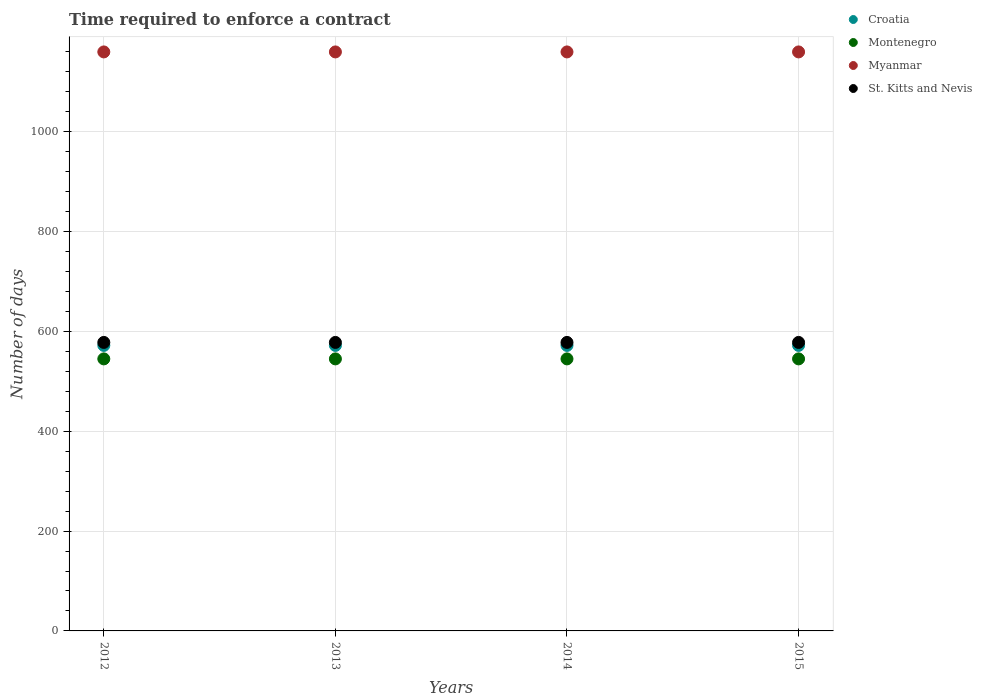What is the number of days required to enforce a contract in Croatia in 2012?
Give a very brief answer. 572. Across all years, what is the maximum number of days required to enforce a contract in St. Kitts and Nevis?
Provide a succinct answer. 578. Across all years, what is the minimum number of days required to enforce a contract in Croatia?
Offer a terse response. 572. In which year was the number of days required to enforce a contract in Croatia maximum?
Your answer should be compact. 2012. In which year was the number of days required to enforce a contract in St. Kitts and Nevis minimum?
Provide a short and direct response. 2012. What is the total number of days required to enforce a contract in Myanmar in the graph?
Your answer should be compact. 4640. What is the difference between the number of days required to enforce a contract in Myanmar in 2015 and the number of days required to enforce a contract in St. Kitts and Nevis in 2013?
Give a very brief answer. 582. What is the average number of days required to enforce a contract in St. Kitts and Nevis per year?
Ensure brevity in your answer.  578. In the year 2012, what is the difference between the number of days required to enforce a contract in Myanmar and number of days required to enforce a contract in St. Kitts and Nevis?
Your answer should be very brief. 582. Is the difference between the number of days required to enforce a contract in Myanmar in 2014 and 2015 greater than the difference between the number of days required to enforce a contract in St. Kitts and Nevis in 2014 and 2015?
Give a very brief answer. No. What is the difference between the highest and the second highest number of days required to enforce a contract in Croatia?
Offer a terse response. 0. Is the number of days required to enforce a contract in Croatia strictly greater than the number of days required to enforce a contract in Myanmar over the years?
Offer a very short reply. No. Is the number of days required to enforce a contract in Myanmar strictly less than the number of days required to enforce a contract in Croatia over the years?
Keep it short and to the point. No. How many years are there in the graph?
Give a very brief answer. 4. What is the difference between two consecutive major ticks on the Y-axis?
Offer a very short reply. 200. Are the values on the major ticks of Y-axis written in scientific E-notation?
Your response must be concise. No. Does the graph contain grids?
Your response must be concise. Yes. How many legend labels are there?
Your answer should be compact. 4. What is the title of the graph?
Make the answer very short. Time required to enforce a contract. What is the label or title of the X-axis?
Provide a short and direct response. Years. What is the label or title of the Y-axis?
Your answer should be very brief. Number of days. What is the Number of days of Croatia in 2012?
Ensure brevity in your answer.  572. What is the Number of days in Montenegro in 2012?
Provide a short and direct response. 545. What is the Number of days in Myanmar in 2012?
Keep it short and to the point. 1160. What is the Number of days of St. Kitts and Nevis in 2012?
Offer a terse response. 578. What is the Number of days in Croatia in 2013?
Ensure brevity in your answer.  572. What is the Number of days in Montenegro in 2013?
Offer a terse response. 545. What is the Number of days of Myanmar in 2013?
Your response must be concise. 1160. What is the Number of days of St. Kitts and Nevis in 2013?
Your response must be concise. 578. What is the Number of days of Croatia in 2014?
Make the answer very short. 572. What is the Number of days in Montenegro in 2014?
Provide a succinct answer. 545. What is the Number of days of Myanmar in 2014?
Your answer should be compact. 1160. What is the Number of days of St. Kitts and Nevis in 2014?
Give a very brief answer. 578. What is the Number of days in Croatia in 2015?
Ensure brevity in your answer.  572. What is the Number of days of Montenegro in 2015?
Give a very brief answer. 545. What is the Number of days in Myanmar in 2015?
Keep it short and to the point. 1160. What is the Number of days in St. Kitts and Nevis in 2015?
Your answer should be very brief. 578. Across all years, what is the maximum Number of days in Croatia?
Make the answer very short. 572. Across all years, what is the maximum Number of days of Montenegro?
Provide a short and direct response. 545. Across all years, what is the maximum Number of days of Myanmar?
Ensure brevity in your answer.  1160. Across all years, what is the maximum Number of days in St. Kitts and Nevis?
Offer a very short reply. 578. Across all years, what is the minimum Number of days in Croatia?
Provide a succinct answer. 572. Across all years, what is the minimum Number of days of Montenegro?
Offer a very short reply. 545. Across all years, what is the minimum Number of days in Myanmar?
Keep it short and to the point. 1160. Across all years, what is the minimum Number of days in St. Kitts and Nevis?
Provide a succinct answer. 578. What is the total Number of days of Croatia in the graph?
Your answer should be compact. 2288. What is the total Number of days of Montenegro in the graph?
Give a very brief answer. 2180. What is the total Number of days in Myanmar in the graph?
Offer a very short reply. 4640. What is the total Number of days of St. Kitts and Nevis in the graph?
Offer a terse response. 2312. What is the difference between the Number of days of Montenegro in 2012 and that in 2013?
Your response must be concise. 0. What is the difference between the Number of days in Myanmar in 2012 and that in 2013?
Make the answer very short. 0. What is the difference between the Number of days of St. Kitts and Nevis in 2012 and that in 2013?
Offer a terse response. 0. What is the difference between the Number of days in Montenegro in 2012 and that in 2014?
Give a very brief answer. 0. What is the difference between the Number of days in Myanmar in 2012 and that in 2014?
Give a very brief answer. 0. What is the difference between the Number of days of St. Kitts and Nevis in 2012 and that in 2014?
Make the answer very short. 0. What is the difference between the Number of days in Myanmar in 2012 and that in 2015?
Give a very brief answer. 0. What is the difference between the Number of days of St. Kitts and Nevis in 2012 and that in 2015?
Ensure brevity in your answer.  0. What is the difference between the Number of days in Croatia in 2013 and that in 2014?
Provide a short and direct response. 0. What is the difference between the Number of days of Montenegro in 2013 and that in 2014?
Offer a terse response. 0. What is the difference between the Number of days in Croatia in 2013 and that in 2015?
Give a very brief answer. 0. What is the difference between the Number of days in Myanmar in 2013 and that in 2015?
Your response must be concise. 0. What is the difference between the Number of days in Croatia in 2014 and that in 2015?
Your response must be concise. 0. What is the difference between the Number of days in St. Kitts and Nevis in 2014 and that in 2015?
Keep it short and to the point. 0. What is the difference between the Number of days in Croatia in 2012 and the Number of days in Myanmar in 2013?
Give a very brief answer. -588. What is the difference between the Number of days of Montenegro in 2012 and the Number of days of Myanmar in 2013?
Your response must be concise. -615. What is the difference between the Number of days of Montenegro in 2012 and the Number of days of St. Kitts and Nevis in 2013?
Offer a terse response. -33. What is the difference between the Number of days of Myanmar in 2012 and the Number of days of St. Kitts and Nevis in 2013?
Your answer should be very brief. 582. What is the difference between the Number of days of Croatia in 2012 and the Number of days of Montenegro in 2014?
Offer a terse response. 27. What is the difference between the Number of days in Croatia in 2012 and the Number of days in Myanmar in 2014?
Offer a terse response. -588. What is the difference between the Number of days in Montenegro in 2012 and the Number of days in Myanmar in 2014?
Give a very brief answer. -615. What is the difference between the Number of days of Montenegro in 2012 and the Number of days of St. Kitts and Nevis in 2014?
Provide a succinct answer. -33. What is the difference between the Number of days in Myanmar in 2012 and the Number of days in St. Kitts and Nevis in 2014?
Provide a succinct answer. 582. What is the difference between the Number of days of Croatia in 2012 and the Number of days of Myanmar in 2015?
Provide a short and direct response. -588. What is the difference between the Number of days in Croatia in 2012 and the Number of days in St. Kitts and Nevis in 2015?
Provide a succinct answer. -6. What is the difference between the Number of days of Montenegro in 2012 and the Number of days of Myanmar in 2015?
Your answer should be compact. -615. What is the difference between the Number of days of Montenegro in 2012 and the Number of days of St. Kitts and Nevis in 2015?
Keep it short and to the point. -33. What is the difference between the Number of days in Myanmar in 2012 and the Number of days in St. Kitts and Nevis in 2015?
Ensure brevity in your answer.  582. What is the difference between the Number of days of Croatia in 2013 and the Number of days of Montenegro in 2014?
Provide a short and direct response. 27. What is the difference between the Number of days in Croatia in 2013 and the Number of days in Myanmar in 2014?
Your answer should be compact. -588. What is the difference between the Number of days of Croatia in 2013 and the Number of days of St. Kitts and Nevis in 2014?
Your answer should be compact. -6. What is the difference between the Number of days of Montenegro in 2013 and the Number of days of Myanmar in 2014?
Provide a short and direct response. -615. What is the difference between the Number of days of Montenegro in 2013 and the Number of days of St. Kitts and Nevis in 2014?
Ensure brevity in your answer.  -33. What is the difference between the Number of days of Myanmar in 2013 and the Number of days of St. Kitts and Nevis in 2014?
Make the answer very short. 582. What is the difference between the Number of days of Croatia in 2013 and the Number of days of Montenegro in 2015?
Your answer should be very brief. 27. What is the difference between the Number of days of Croatia in 2013 and the Number of days of Myanmar in 2015?
Provide a succinct answer. -588. What is the difference between the Number of days in Croatia in 2013 and the Number of days in St. Kitts and Nevis in 2015?
Provide a succinct answer. -6. What is the difference between the Number of days in Montenegro in 2013 and the Number of days in Myanmar in 2015?
Provide a short and direct response. -615. What is the difference between the Number of days in Montenegro in 2013 and the Number of days in St. Kitts and Nevis in 2015?
Provide a succinct answer. -33. What is the difference between the Number of days of Myanmar in 2013 and the Number of days of St. Kitts and Nevis in 2015?
Your answer should be compact. 582. What is the difference between the Number of days of Croatia in 2014 and the Number of days of Montenegro in 2015?
Offer a terse response. 27. What is the difference between the Number of days in Croatia in 2014 and the Number of days in Myanmar in 2015?
Offer a terse response. -588. What is the difference between the Number of days in Montenegro in 2014 and the Number of days in Myanmar in 2015?
Offer a terse response. -615. What is the difference between the Number of days of Montenegro in 2014 and the Number of days of St. Kitts and Nevis in 2015?
Offer a very short reply. -33. What is the difference between the Number of days in Myanmar in 2014 and the Number of days in St. Kitts and Nevis in 2015?
Give a very brief answer. 582. What is the average Number of days of Croatia per year?
Provide a short and direct response. 572. What is the average Number of days in Montenegro per year?
Keep it short and to the point. 545. What is the average Number of days of Myanmar per year?
Keep it short and to the point. 1160. What is the average Number of days of St. Kitts and Nevis per year?
Keep it short and to the point. 578. In the year 2012, what is the difference between the Number of days in Croatia and Number of days in Montenegro?
Keep it short and to the point. 27. In the year 2012, what is the difference between the Number of days of Croatia and Number of days of Myanmar?
Make the answer very short. -588. In the year 2012, what is the difference between the Number of days of Montenegro and Number of days of Myanmar?
Your answer should be compact. -615. In the year 2012, what is the difference between the Number of days in Montenegro and Number of days in St. Kitts and Nevis?
Make the answer very short. -33. In the year 2012, what is the difference between the Number of days in Myanmar and Number of days in St. Kitts and Nevis?
Your answer should be very brief. 582. In the year 2013, what is the difference between the Number of days in Croatia and Number of days in Myanmar?
Your response must be concise. -588. In the year 2013, what is the difference between the Number of days of Croatia and Number of days of St. Kitts and Nevis?
Your answer should be very brief. -6. In the year 2013, what is the difference between the Number of days of Montenegro and Number of days of Myanmar?
Your answer should be compact. -615. In the year 2013, what is the difference between the Number of days of Montenegro and Number of days of St. Kitts and Nevis?
Keep it short and to the point. -33. In the year 2013, what is the difference between the Number of days of Myanmar and Number of days of St. Kitts and Nevis?
Give a very brief answer. 582. In the year 2014, what is the difference between the Number of days of Croatia and Number of days of Myanmar?
Provide a short and direct response. -588. In the year 2014, what is the difference between the Number of days in Croatia and Number of days in St. Kitts and Nevis?
Provide a succinct answer. -6. In the year 2014, what is the difference between the Number of days of Montenegro and Number of days of Myanmar?
Offer a very short reply. -615. In the year 2014, what is the difference between the Number of days of Montenegro and Number of days of St. Kitts and Nevis?
Ensure brevity in your answer.  -33. In the year 2014, what is the difference between the Number of days in Myanmar and Number of days in St. Kitts and Nevis?
Keep it short and to the point. 582. In the year 2015, what is the difference between the Number of days in Croatia and Number of days in Myanmar?
Offer a terse response. -588. In the year 2015, what is the difference between the Number of days in Croatia and Number of days in St. Kitts and Nevis?
Provide a succinct answer. -6. In the year 2015, what is the difference between the Number of days in Montenegro and Number of days in Myanmar?
Provide a succinct answer. -615. In the year 2015, what is the difference between the Number of days of Montenegro and Number of days of St. Kitts and Nevis?
Your response must be concise. -33. In the year 2015, what is the difference between the Number of days of Myanmar and Number of days of St. Kitts and Nevis?
Keep it short and to the point. 582. What is the ratio of the Number of days in Montenegro in 2012 to that in 2013?
Your answer should be compact. 1. What is the ratio of the Number of days in Croatia in 2012 to that in 2014?
Your answer should be compact. 1. What is the ratio of the Number of days in St. Kitts and Nevis in 2012 to that in 2014?
Provide a short and direct response. 1. What is the ratio of the Number of days of Montenegro in 2012 to that in 2015?
Your answer should be very brief. 1. What is the ratio of the Number of days in Myanmar in 2012 to that in 2015?
Your answer should be very brief. 1. What is the ratio of the Number of days of St. Kitts and Nevis in 2012 to that in 2015?
Your answer should be compact. 1. What is the ratio of the Number of days of Myanmar in 2013 to that in 2014?
Keep it short and to the point. 1. What is the ratio of the Number of days in St. Kitts and Nevis in 2013 to that in 2014?
Your response must be concise. 1. What is the ratio of the Number of days in Croatia in 2013 to that in 2015?
Keep it short and to the point. 1. What is the ratio of the Number of days in Montenegro in 2013 to that in 2015?
Provide a succinct answer. 1. What is the ratio of the Number of days in Myanmar in 2013 to that in 2015?
Offer a very short reply. 1. What is the ratio of the Number of days of Montenegro in 2014 to that in 2015?
Ensure brevity in your answer.  1. What is the difference between the highest and the second highest Number of days in Myanmar?
Provide a succinct answer. 0. What is the difference between the highest and the second highest Number of days in St. Kitts and Nevis?
Provide a succinct answer. 0. What is the difference between the highest and the lowest Number of days of Montenegro?
Offer a terse response. 0. 